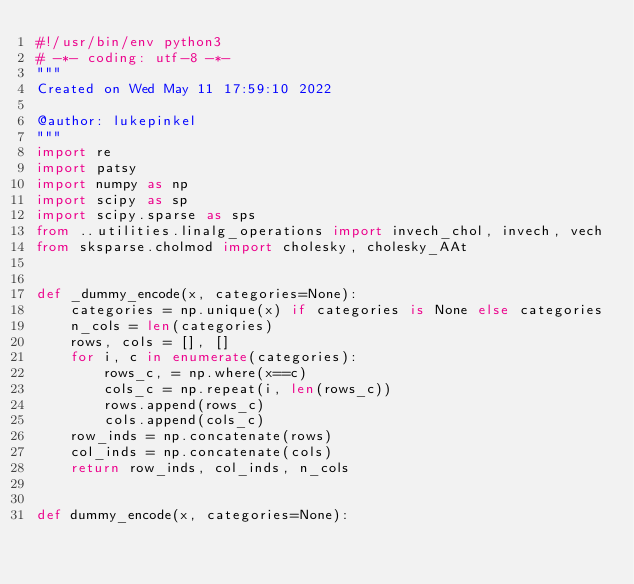Convert code to text. <code><loc_0><loc_0><loc_500><loc_500><_Python_>#!/usr/bin/env python3
# -*- coding: utf-8 -*-
"""
Created on Wed May 11 17:59:10 2022

@author: lukepinkel
"""
import re
import patsy
import numpy as np
import scipy as sp
import scipy.sparse as sps
from ..utilities.linalg_operations import invech_chol, invech, vech
from sksparse.cholmod import cholesky, cholesky_AAt


def _dummy_encode(x, categories=None):
    categories = np.unique(x) if categories is None else categories
    n_cols = len(categories)
    rows, cols = [], []
    for i, c in enumerate(categories):
        rows_c, = np.where(x==c)
        cols_c = np.repeat(i, len(rows_c))
        rows.append(rows_c)
        cols.append(cols_c)
    row_inds = np.concatenate(rows)
    col_inds = np.concatenate(cols)
    return row_inds, col_inds, n_cols


def dummy_encode(x, categories=None):</code> 